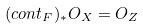<formula> <loc_0><loc_0><loc_500><loc_500>( c o n t _ { F } ) _ { * } O _ { X } = O _ { Z }</formula> 